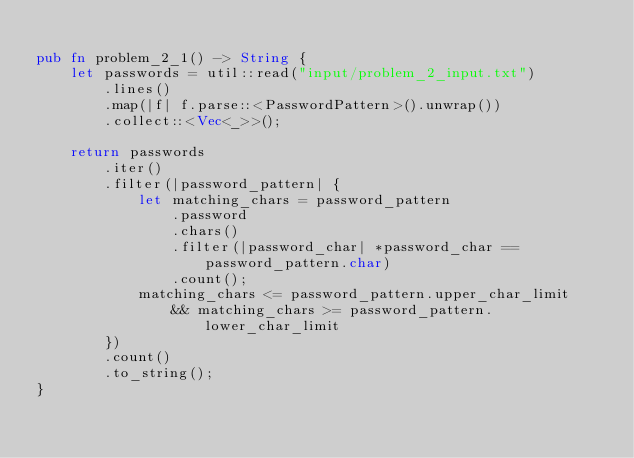Convert code to text. <code><loc_0><loc_0><loc_500><loc_500><_Rust_>
pub fn problem_2_1() -> String {
    let passwords = util::read("input/problem_2_input.txt")
        .lines()
        .map(|f| f.parse::<PasswordPattern>().unwrap())
        .collect::<Vec<_>>();

    return passwords
        .iter()
        .filter(|password_pattern| {
            let matching_chars = password_pattern
                .password
                .chars()
                .filter(|password_char| *password_char == password_pattern.char)
                .count();
            matching_chars <= password_pattern.upper_char_limit
                && matching_chars >= password_pattern.lower_char_limit
        })
        .count()
        .to_string();
}
</code> 